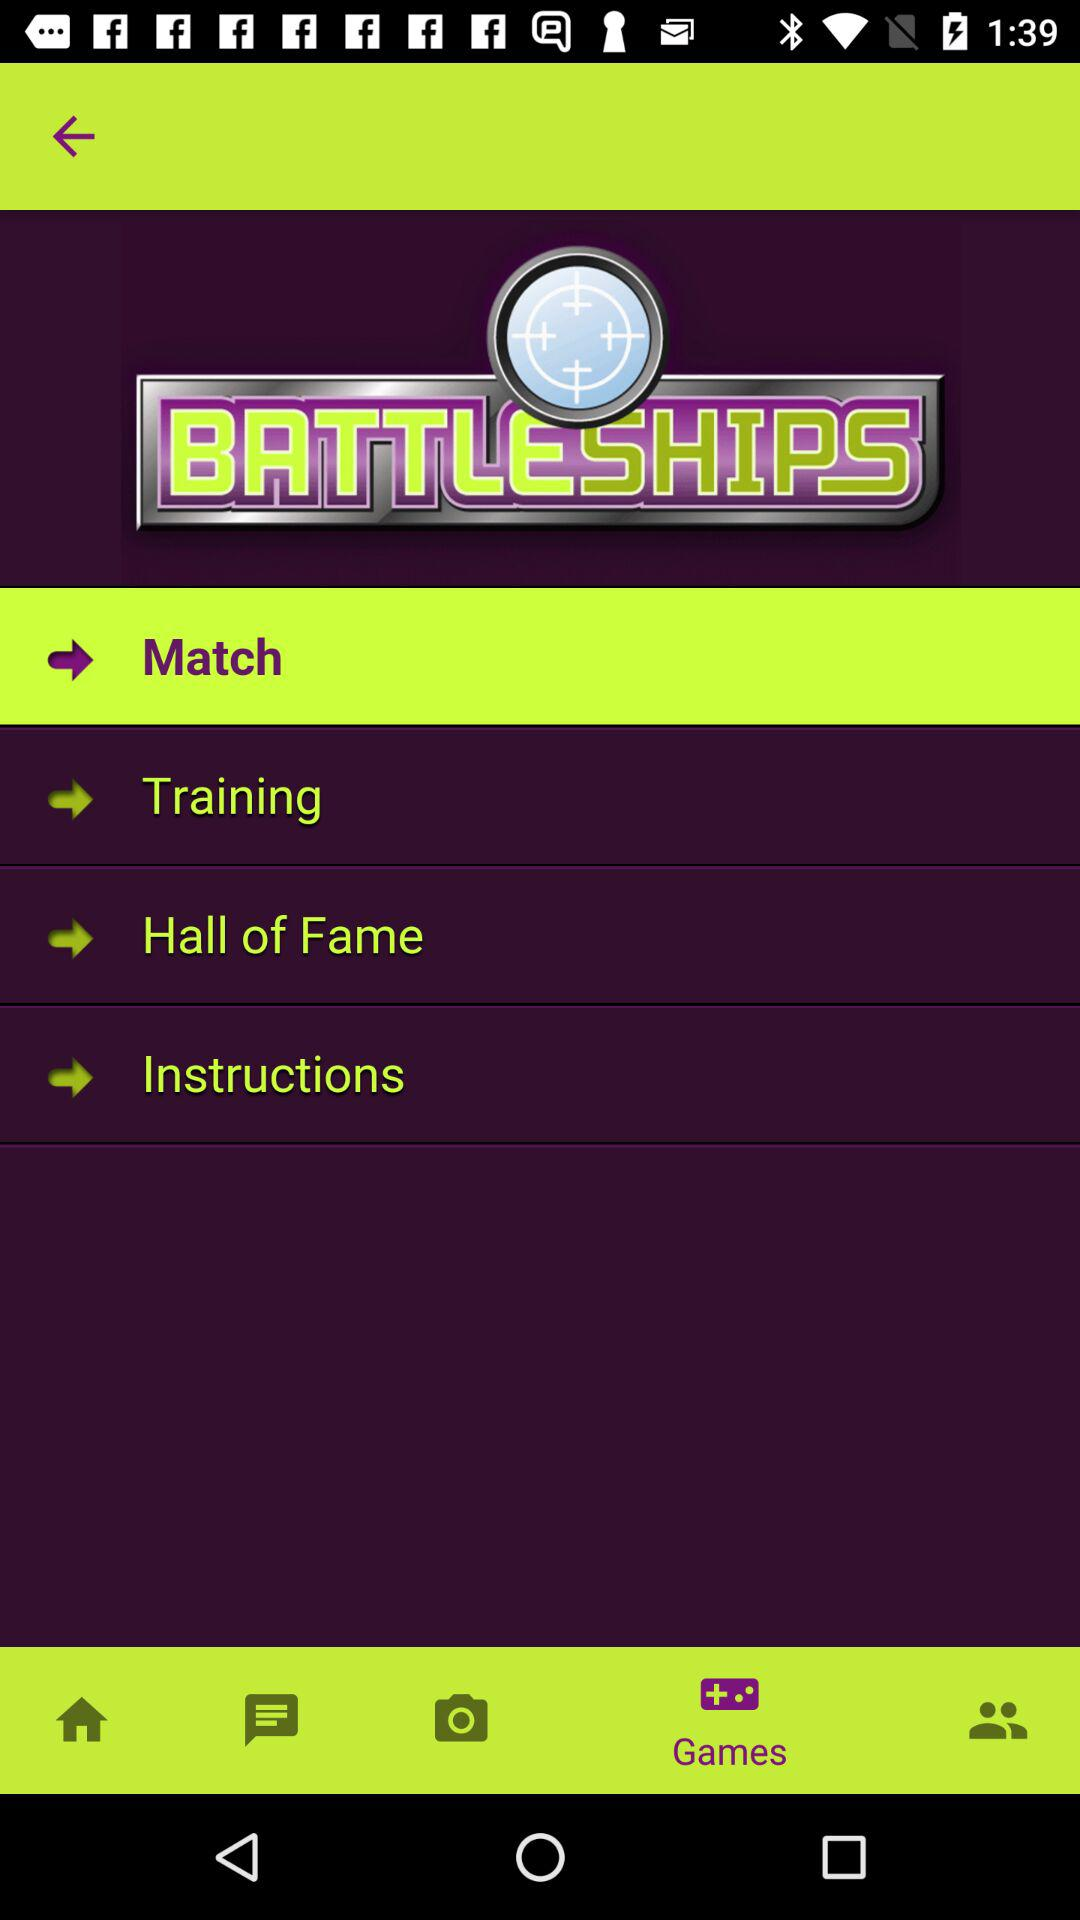Which tab is selected? The selected tab is "Games". 